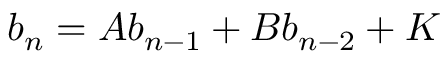<formula> <loc_0><loc_0><loc_500><loc_500>b _ { n } = A b _ { n - 1 } + B b _ { n - 2 } + K</formula> 